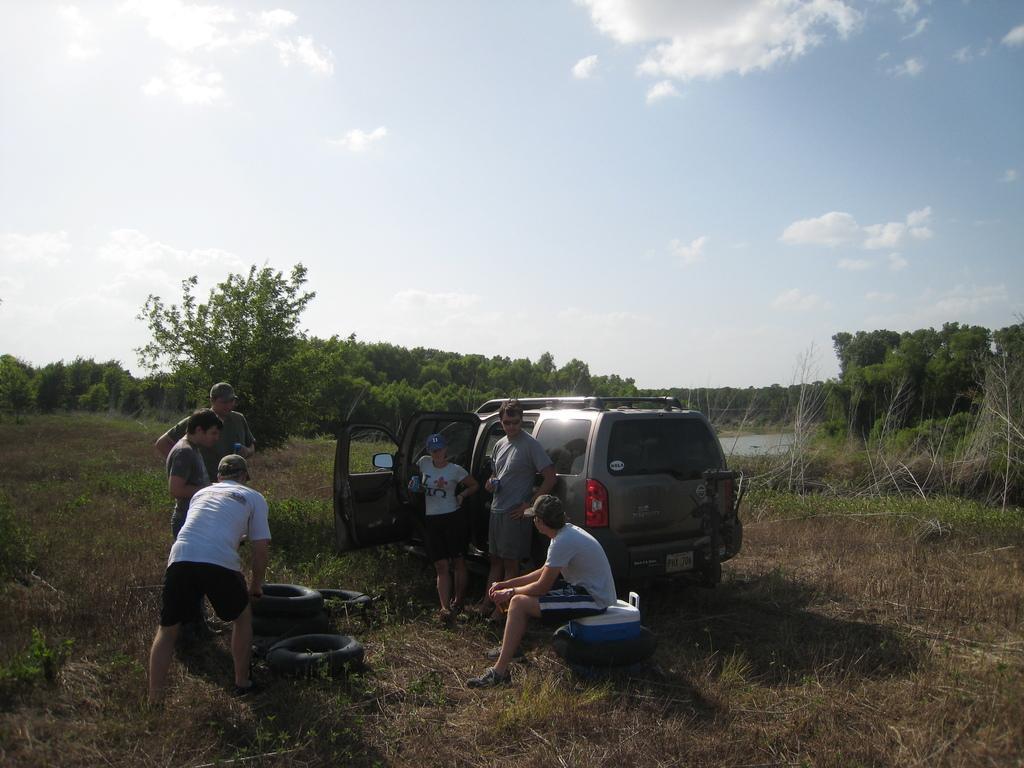How would you summarize this image in a sentence or two? Here we can see few persons are standing on the ground and a person is sitting on the objects on the ground. In the background there are trees, vehicle, water and clouds in the sky. 